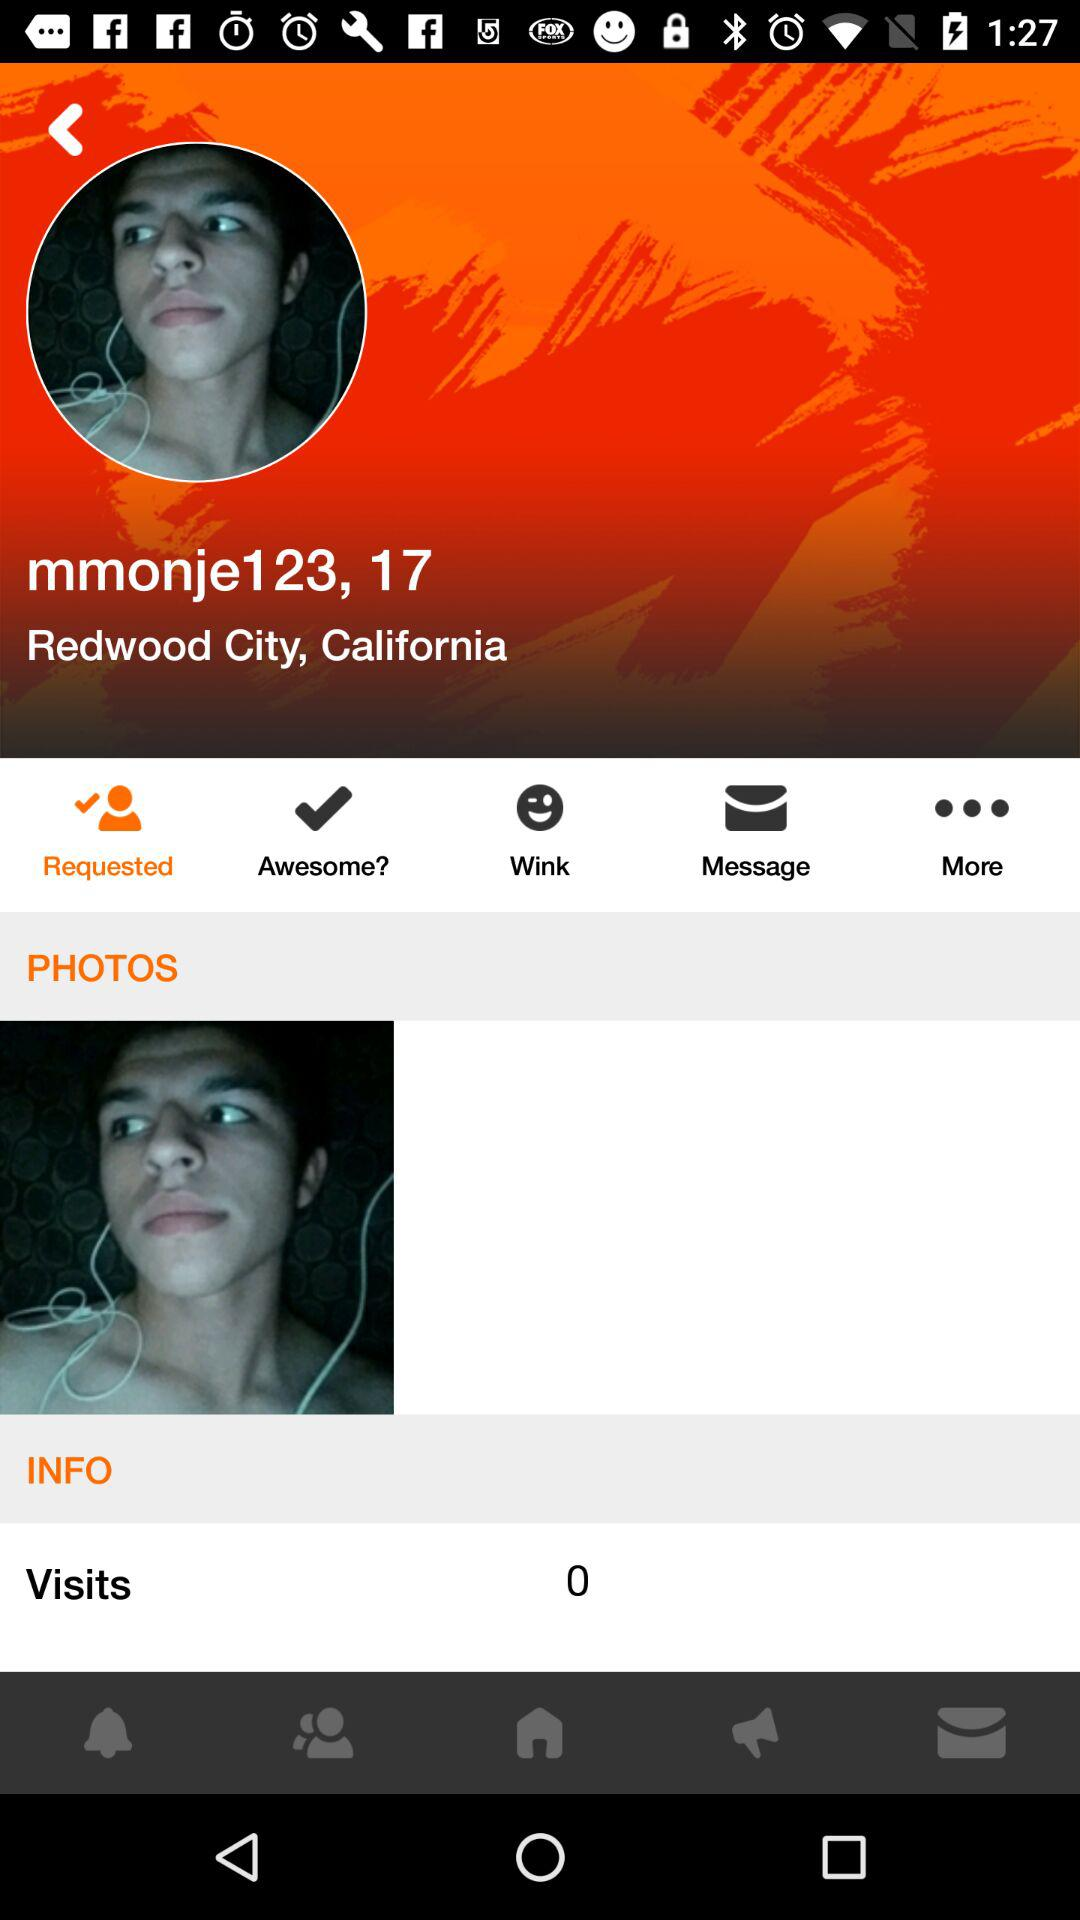In what city does "mmonje123" live? "mmonje123" lives in Redwood City. 